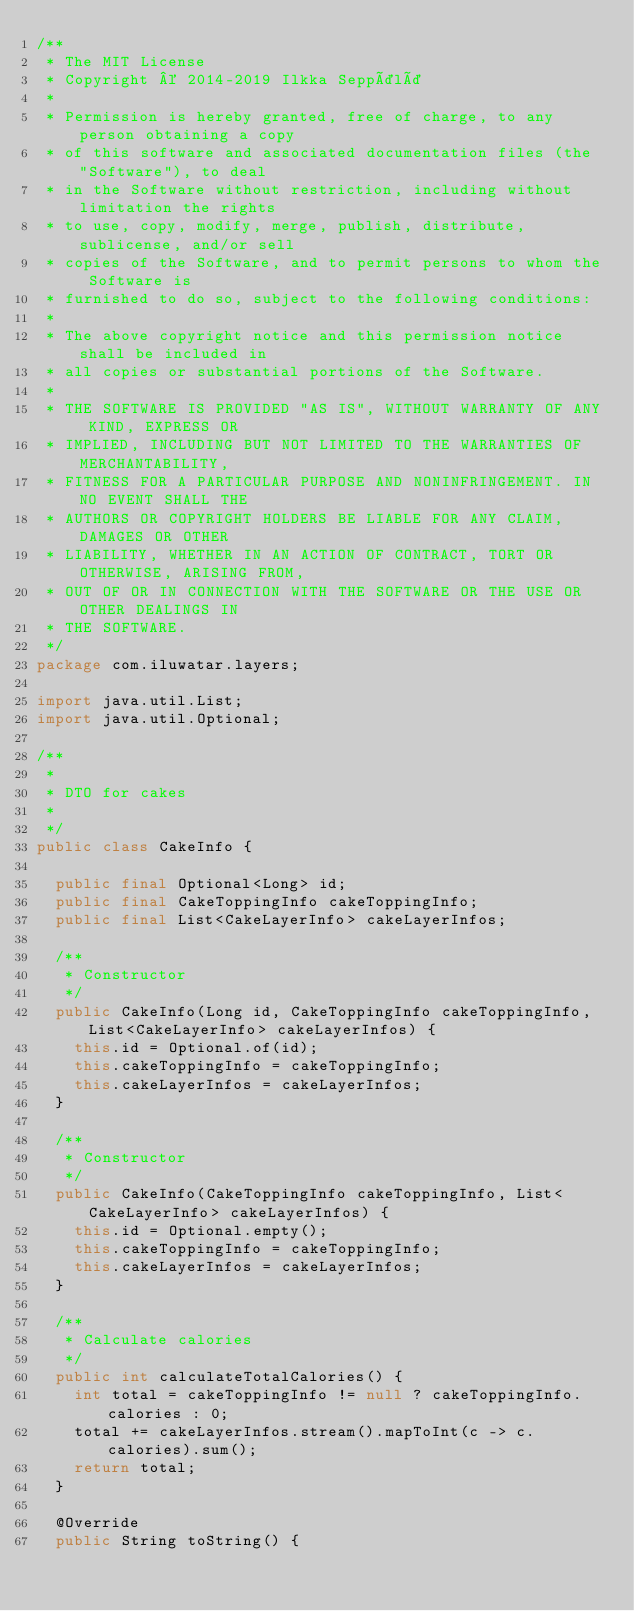Convert code to text. <code><loc_0><loc_0><loc_500><loc_500><_Java_>/**
 * The MIT License
 * Copyright © 2014-2019 Ilkka Seppälä
 *
 * Permission is hereby granted, free of charge, to any person obtaining a copy
 * of this software and associated documentation files (the "Software"), to deal
 * in the Software without restriction, including without limitation the rights
 * to use, copy, modify, merge, publish, distribute, sublicense, and/or sell
 * copies of the Software, and to permit persons to whom the Software is
 * furnished to do so, subject to the following conditions:
 *
 * The above copyright notice and this permission notice shall be included in
 * all copies or substantial portions of the Software.
 *
 * THE SOFTWARE IS PROVIDED "AS IS", WITHOUT WARRANTY OF ANY KIND, EXPRESS OR
 * IMPLIED, INCLUDING BUT NOT LIMITED TO THE WARRANTIES OF MERCHANTABILITY,
 * FITNESS FOR A PARTICULAR PURPOSE AND NONINFRINGEMENT. IN NO EVENT SHALL THE
 * AUTHORS OR COPYRIGHT HOLDERS BE LIABLE FOR ANY CLAIM, DAMAGES OR OTHER
 * LIABILITY, WHETHER IN AN ACTION OF CONTRACT, TORT OR OTHERWISE, ARISING FROM,
 * OUT OF OR IN CONNECTION WITH THE SOFTWARE OR THE USE OR OTHER DEALINGS IN
 * THE SOFTWARE.
 */
package com.iluwatar.layers;

import java.util.List;
import java.util.Optional;

/**
 * 
 * DTO for cakes
 *
 */
public class CakeInfo {

  public final Optional<Long> id;
  public final CakeToppingInfo cakeToppingInfo;
  public final List<CakeLayerInfo> cakeLayerInfos;

  /**
   * Constructor
   */
  public CakeInfo(Long id, CakeToppingInfo cakeToppingInfo, List<CakeLayerInfo> cakeLayerInfos) {
    this.id = Optional.of(id);
    this.cakeToppingInfo = cakeToppingInfo;
    this.cakeLayerInfos = cakeLayerInfos;
  }

  /**
   * Constructor
   */
  public CakeInfo(CakeToppingInfo cakeToppingInfo, List<CakeLayerInfo> cakeLayerInfos) {
    this.id = Optional.empty();
    this.cakeToppingInfo = cakeToppingInfo;
    this.cakeLayerInfos = cakeLayerInfos;
  }

  /**
   * Calculate calories
   */
  public int calculateTotalCalories() {
    int total = cakeToppingInfo != null ? cakeToppingInfo.calories : 0;
    total += cakeLayerInfos.stream().mapToInt(c -> c.calories).sum();
    return total;
  }

  @Override
  public String toString() {</code> 